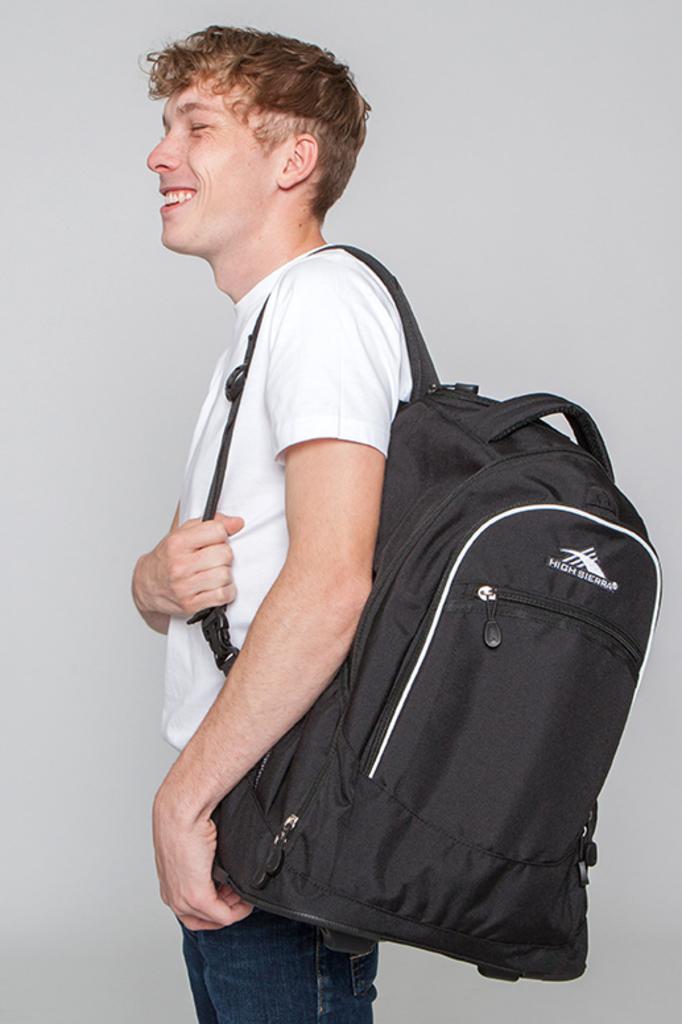Please provide a concise description of this image. He is standing. His wearing a bag and his smiling. 